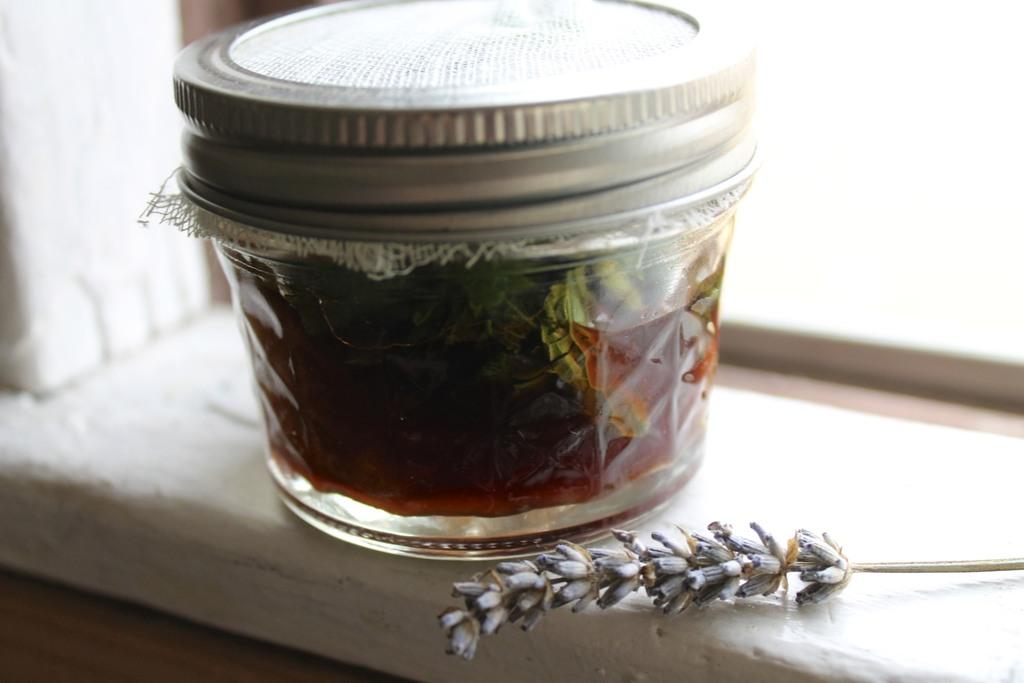What is inside the jar that is visible in the image? There is a jar with some liquid in the image, and leaves are also present in the jar. What is the texture of the object in the image? The object in the image is dry. What is the color of the surface on which the jar is placed? The jar is on a white color surface. How many deer can be seen grazing on the substance in the image? There are no deer or grazing substance present in the image. 